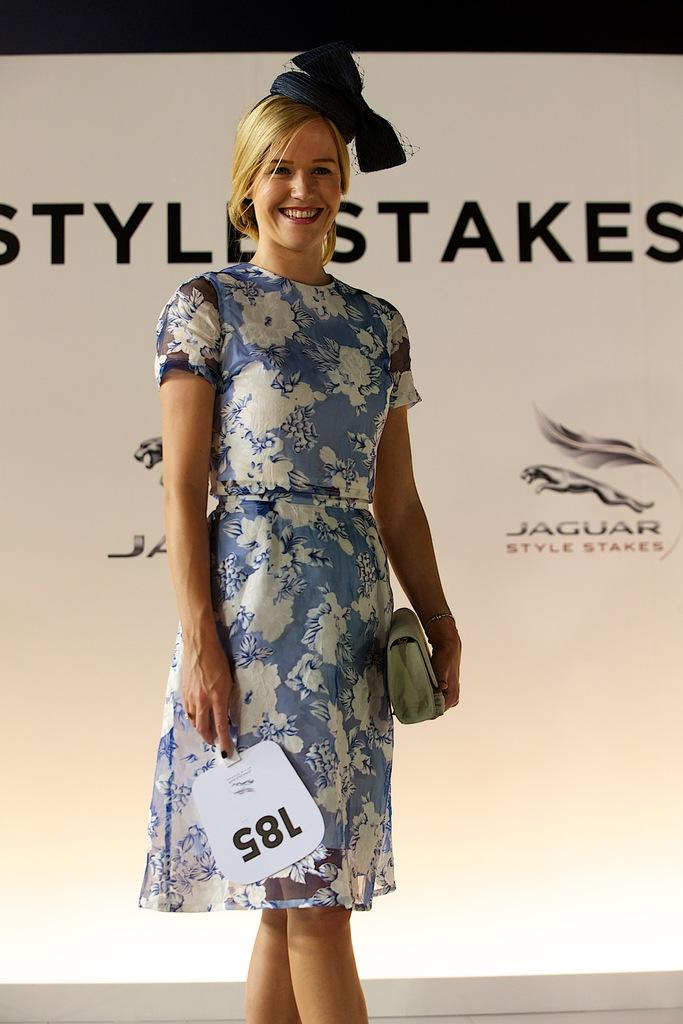Who is present in the image? There is a woman in the image. What is the woman doing in the image? The woman is standing in the image. What is the woman's facial expression in the image? The woman is smiling in the image. What can be seen in the background of the image? There are posters of company names in the background. What type of religious ceremony is taking place in the image? There is no indication of a religious ceremony in the image; it features a woman standing and smiling with posters of company names in the background. Can you tell me how many chess pieces are visible on the table in the image? There is no table or chess pieces present in the image. 